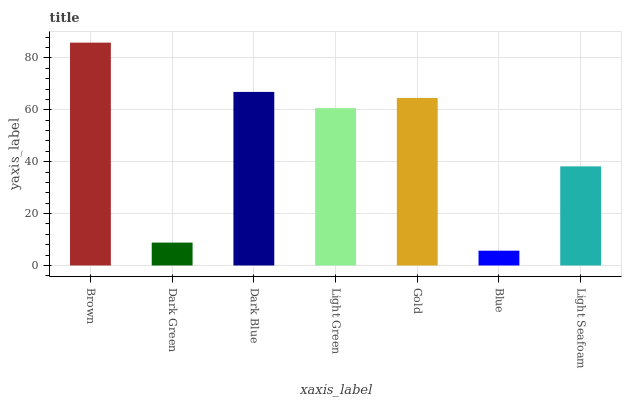Is Dark Green the minimum?
Answer yes or no. No. Is Dark Green the maximum?
Answer yes or no. No. Is Brown greater than Dark Green?
Answer yes or no. Yes. Is Dark Green less than Brown?
Answer yes or no. Yes. Is Dark Green greater than Brown?
Answer yes or no. No. Is Brown less than Dark Green?
Answer yes or no. No. Is Light Green the high median?
Answer yes or no. Yes. Is Light Green the low median?
Answer yes or no. Yes. Is Light Seafoam the high median?
Answer yes or no. No. Is Dark Blue the low median?
Answer yes or no. No. 